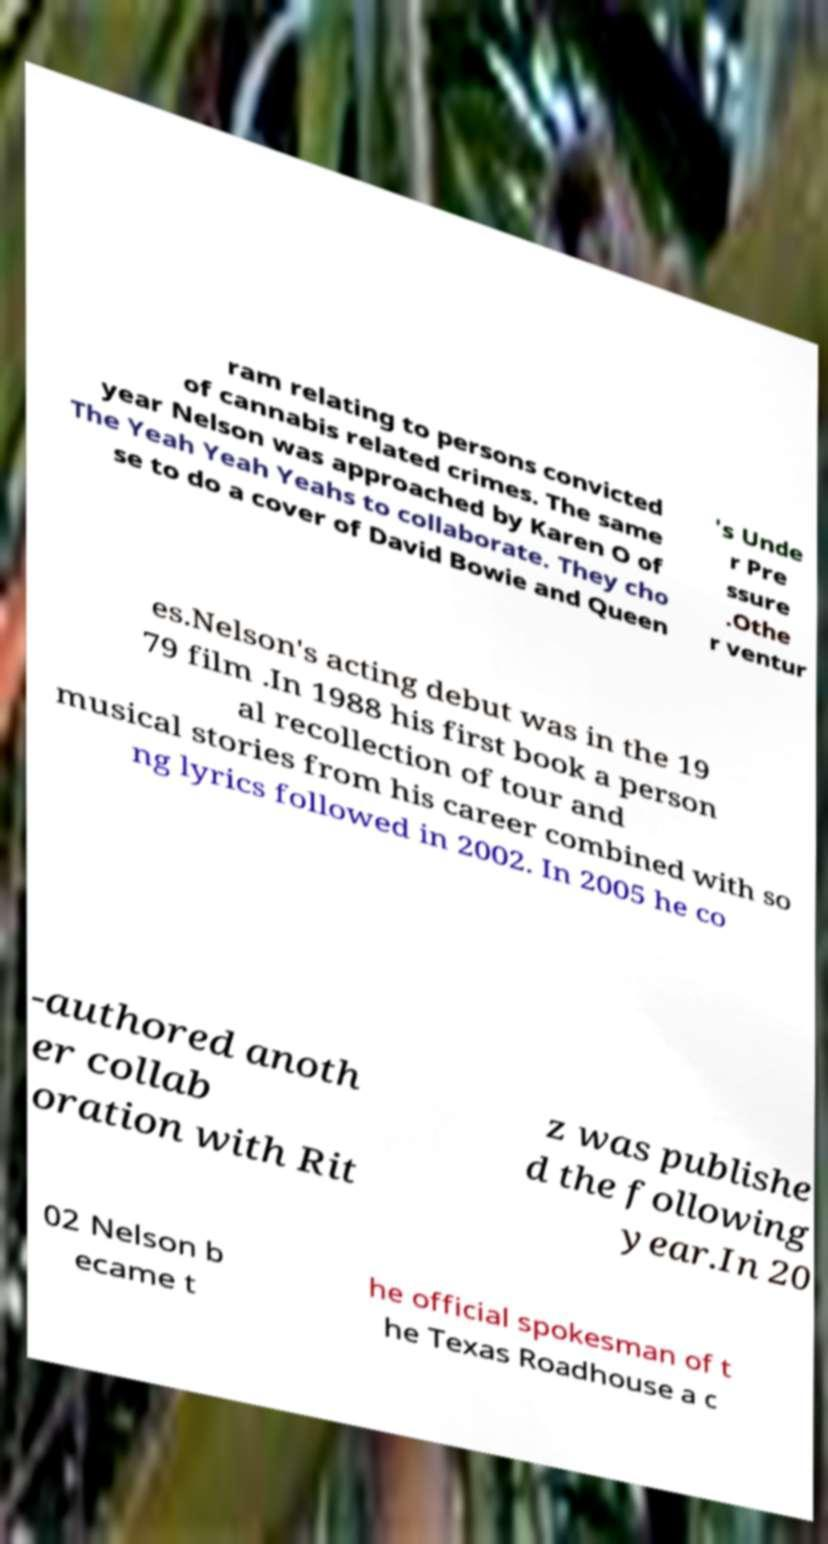Please read and relay the text visible in this image. What does it say? ram relating to persons convicted of cannabis related crimes. The same year Nelson was approached by Karen O of The Yeah Yeah Yeahs to collaborate. They cho se to do a cover of David Bowie and Queen 's Unde r Pre ssure .Othe r ventur es.Nelson's acting debut was in the 19 79 film .In 1988 his first book a person al recollection of tour and musical stories from his career combined with so ng lyrics followed in 2002. In 2005 he co -authored anoth er collab oration with Rit z was publishe d the following year.In 20 02 Nelson b ecame t he official spokesman of t he Texas Roadhouse a c 